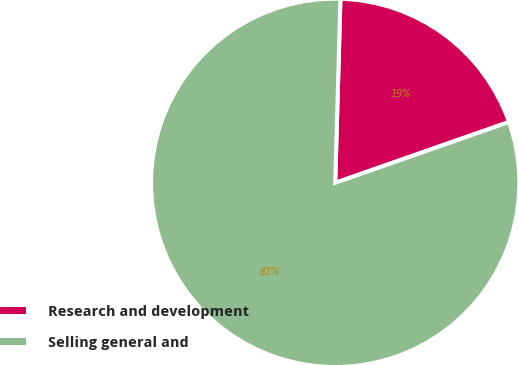Convert chart. <chart><loc_0><loc_0><loc_500><loc_500><pie_chart><fcel>Research and development<fcel>Selling general and<nl><fcel>19.19%<fcel>80.81%<nl></chart> 